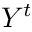Convert formula to latex. <formula><loc_0><loc_0><loc_500><loc_500>Y ^ { t }</formula> 